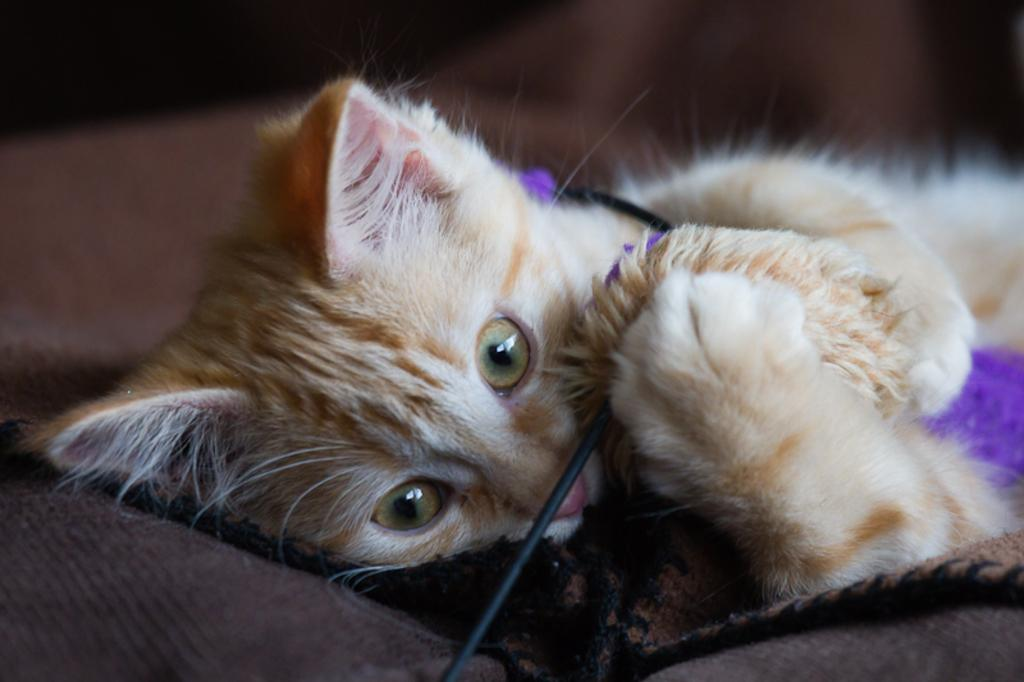What type of animal is in the image? There is a cat in the image. What color is the cat? The cat is brown in color. What is the cat doing in the image? The cat is sleeping. Where is the cat resting in the image? The cat is on a pillow. What color is the pillow the cat is resting on? There is a brown-colored pillow in the image. What type of medical advice does the cat give to the doctor in the image? There is no doctor present in the image, and the cat is not giving any medical advice. 